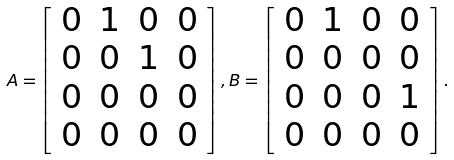Convert formula to latex. <formula><loc_0><loc_0><loc_500><loc_500>A = \left [ \begin{array} { c c c c } 0 & 1 & 0 & 0 \\ 0 & 0 & 1 & 0 \\ 0 & 0 & 0 & 0 \\ 0 & 0 & 0 & 0 \\ \end{array} \right ] , B = \left [ \begin{array} { c c c c } 0 & 1 & 0 & 0 \\ 0 & 0 & 0 & 0 \\ 0 & 0 & 0 & 1 \\ 0 & 0 & 0 & 0 \\ \end{array} \right ] .</formula> 